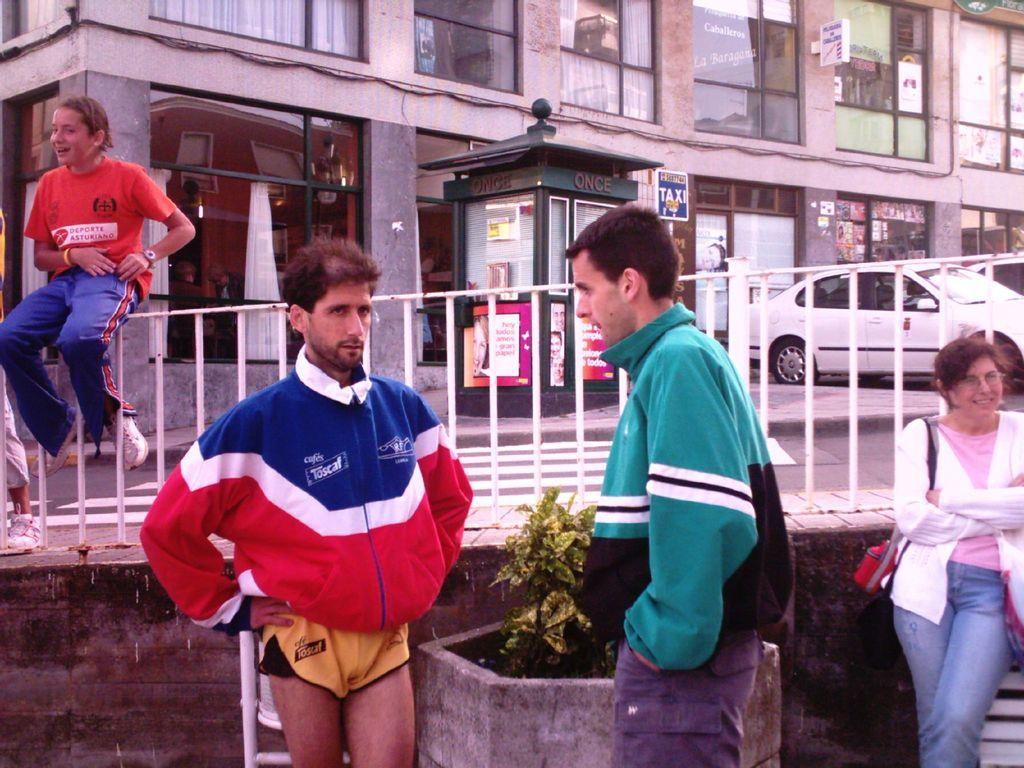<image>
Share a concise interpretation of the image provided. Two men talking infront of a TAXI sign 